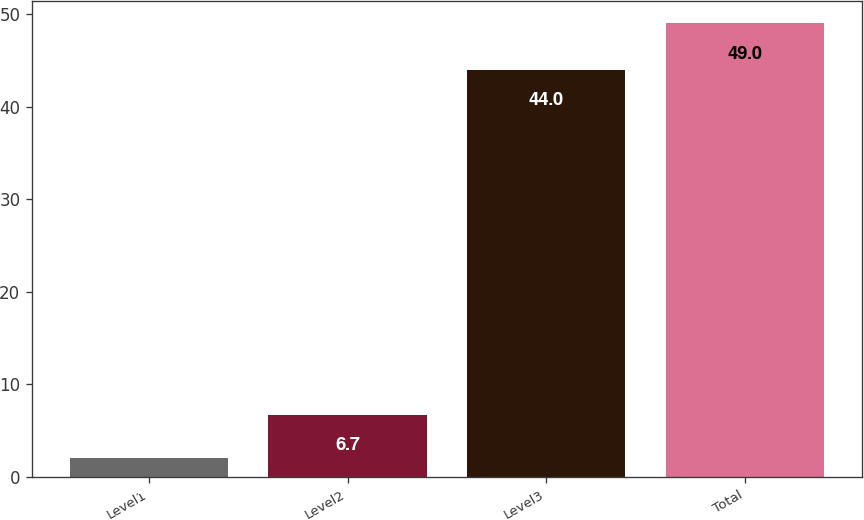Convert chart to OTSL. <chart><loc_0><loc_0><loc_500><loc_500><bar_chart><fcel>Level1<fcel>Level2<fcel>Level3<fcel>Total<nl><fcel>2<fcel>6.7<fcel>44<fcel>49<nl></chart> 